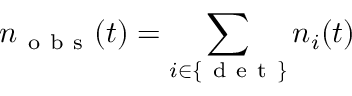<formula> <loc_0><loc_0><loc_500><loc_500>n _ { o b s } ( t ) = \sum _ { i \in \{ d e t \} } n _ { i } ( t )</formula> 